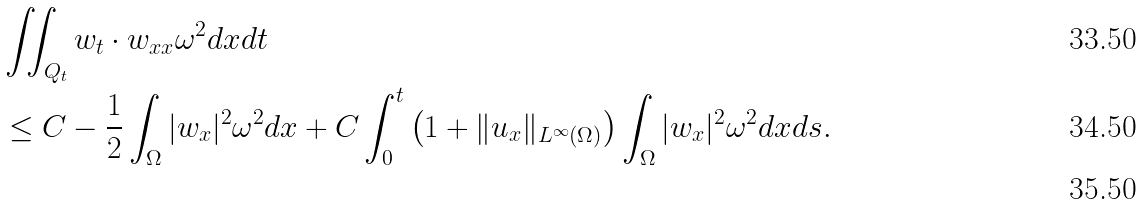<formula> <loc_0><loc_0><loc_500><loc_500>& \iint _ { Q _ { t } } w _ { t } \cdot w _ { x x } \omega ^ { 2 } d x d t \\ & \leq C - \frac { 1 } { 2 } \int _ { \Omega } | w _ { x } | ^ { 2 } \omega ^ { 2 } d x + C \int _ { 0 } ^ { t } \left ( 1 + \| u _ { x } \| _ { L ^ { \infty } ( \Omega ) } \right ) \int _ { \Omega } | w _ { x } | ^ { 2 } \omega ^ { 2 } d x d s . \\</formula> 